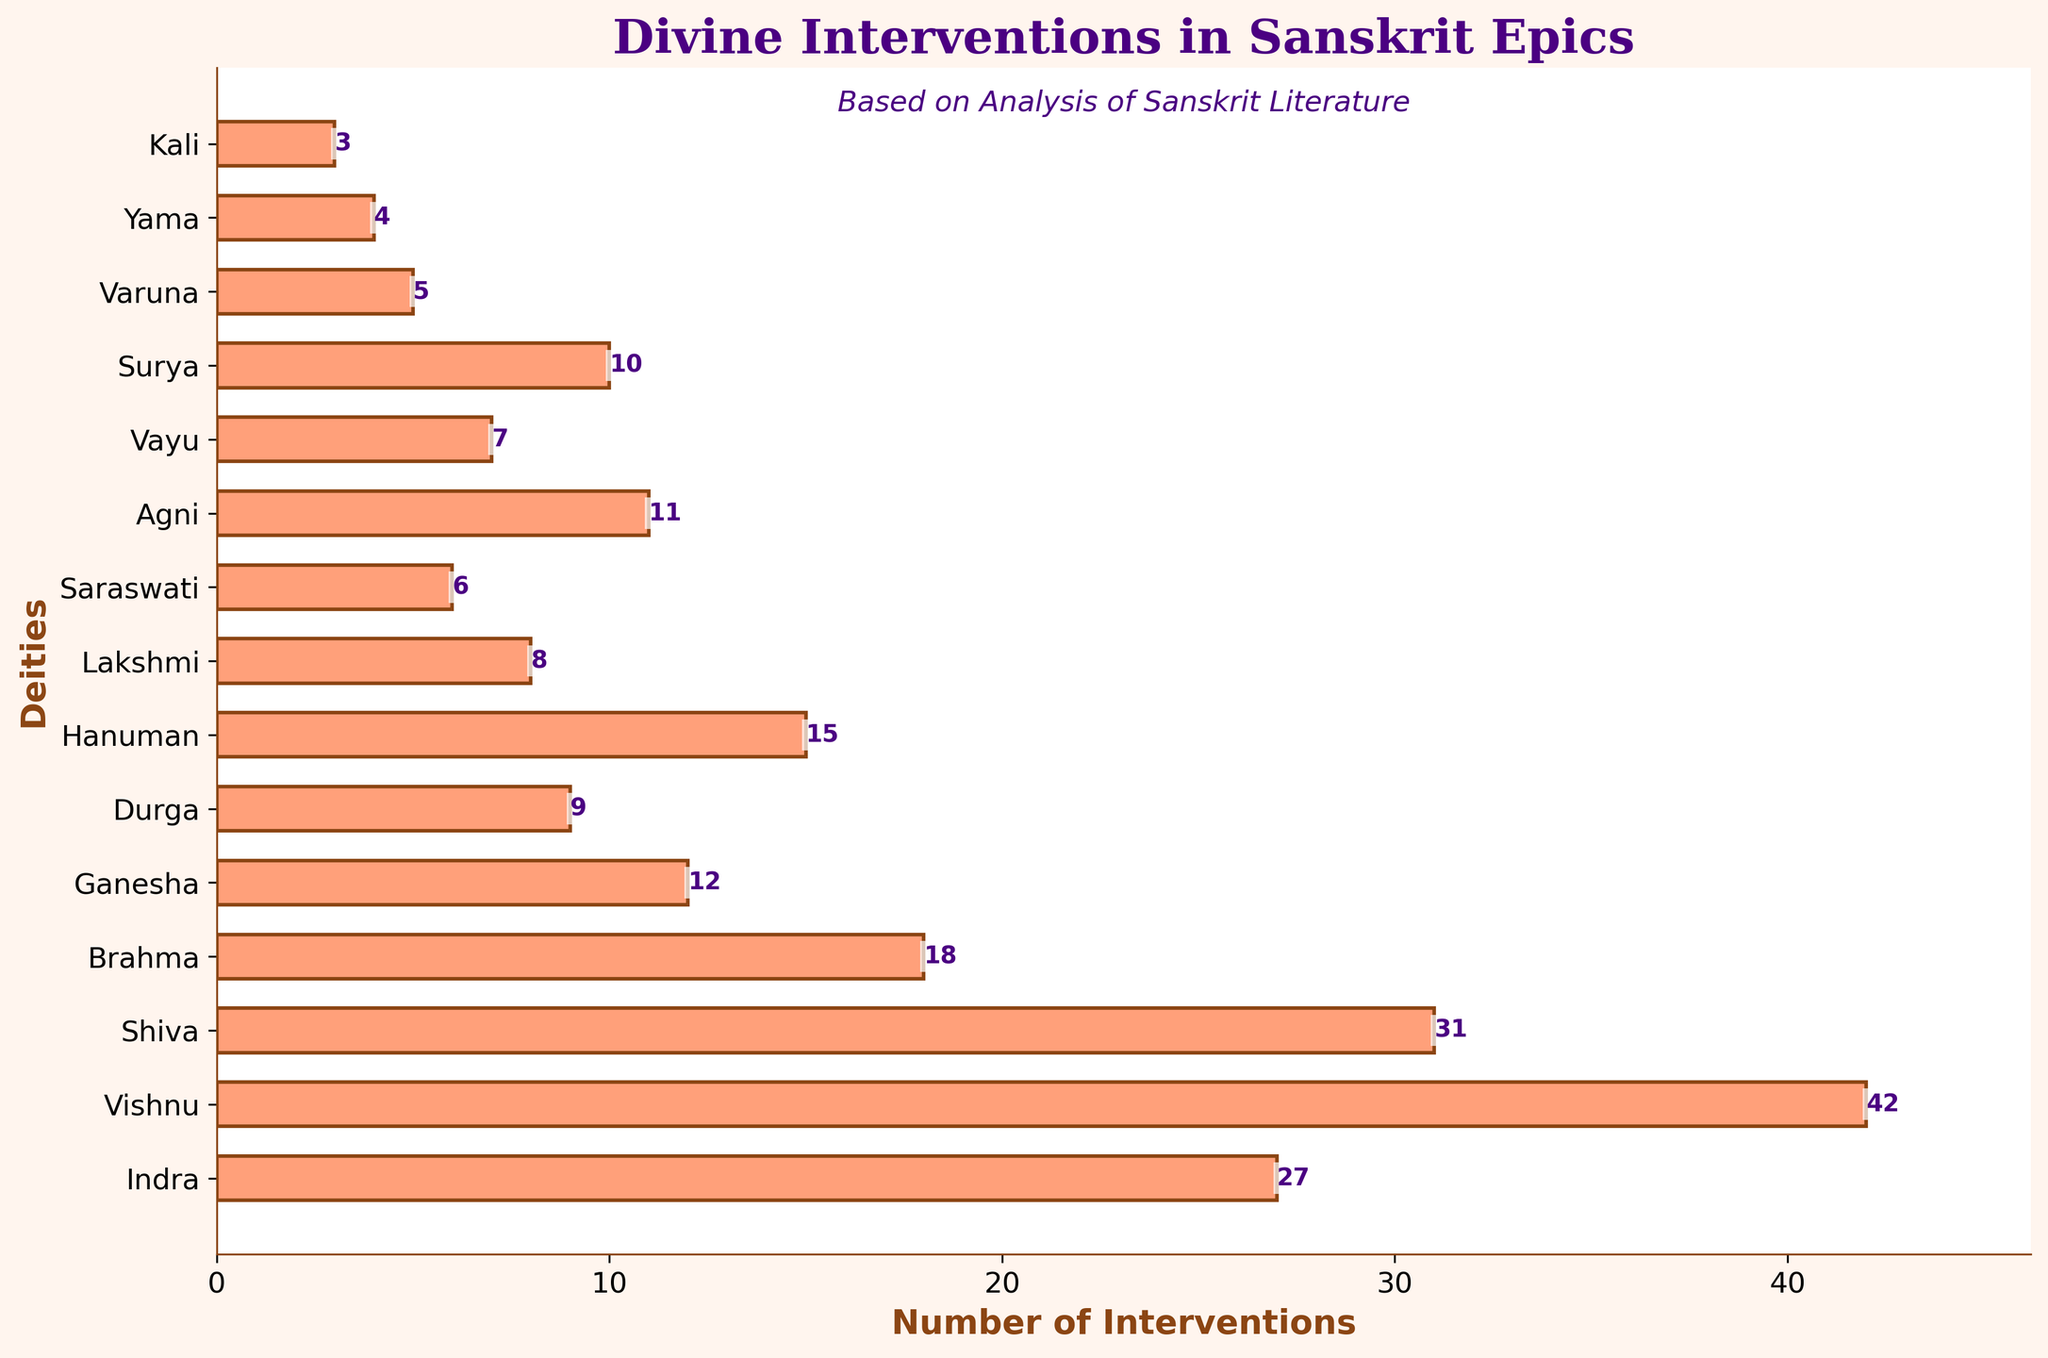What is the deity with the highest number of divine interventions? By visually inspecting the lengths of the bars, Vishnu has the longest bar representing the highest number of divine interventions.
Answer: Vishnu How many more interventions does Shiva have compared to Brahma? By reading the lengths of the bars, Shiva has 31 interventions and Brahma has 18 interventions. The difference is calculated as 31 - 18.
Answer: 13 What is the total number of interventions for all deities combined? Sum the values for all deities: 27 + 42 + 31 + 18 + 12 + 9 + 15 + 8 + 6 + 11 + 7 + 10 + 5 + 4 + 3 = 208.
Answer: 208 Which deities have fewer interventions than Hanuman? By checking the bars visually, deities with fewer interventions than Hanuman (who has 15) include: Brahma, Ganesha, Durga, Lakshmi, Saraswati, Agni, Vayu, Surya, Varuna, Yama, Kali.
Answer: Brahma, Ganesha, Durga, Lakshmi, Saraswati, Agni, Vayu, Surya, Varuna, Yama, Kali What is the average number of divine interventions across all deities? Take the sum of all interventions (208) and divide it by the total number of deities (15), thus 208 / 15 ≈ 13.87.
Answer: ~13.87 How many interventions do Indra, Vishnu, and Shiva have combined? Add the interventions of Indra (27), Vishnu (42), and Shiva (31): 27 + 42 + 31 = 100.
Answer: 100 Which deity has the closest number of interventions to Ganesha? Ganesha has 12 interventions. By observing the bars, Agni with 11 interventions has the closest number to Ganesha.
Answer: Agni What is the difference in the number of interventions between the most and least active deities? The most active deity (Vishnu) has 42 interventions, and the least active deity (Kali) has 3 interventions. The difference is calculated as 42 - 3.
Answer: 39 What is the proportion of Vishnu’s interventions to the total interventions? Vishnu has 42 interventions out of a total of 208. The proportion is calculated as 42 / 208, which simplifies to 1/5 or 0.202.
Answer: ~0.20 (or 20%) How many deities have interventions equal to or greater than 10? By looking at the bars, the deities with interventions equal to or greater than 10 are Indra, Vishnu, Shiva, Brahma, Ganesha, Hanuman, Agni, Surya. Count the deities: 8.
Answer: 8 